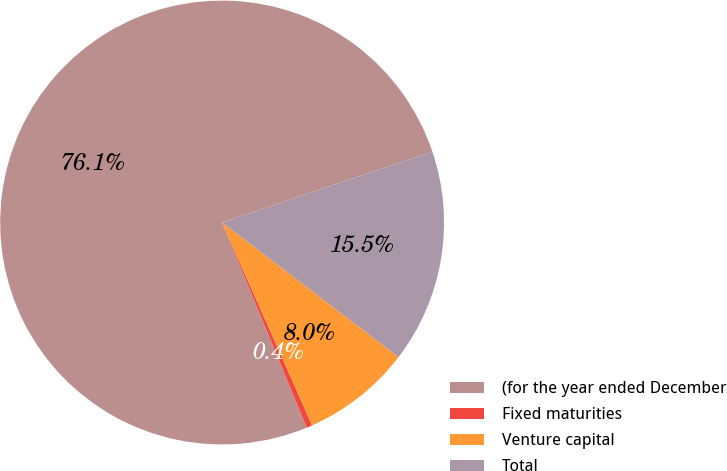Convert chart to OTSL. <chart><loc_0><loc_0><loc_500><loc_500><pie_chart><fcel>(for the year ended December<fcel>Fixed maturities<fcel>Venture capital<fcel>Total<nl><fcel>76.06%<fcel>0.42%<fcel>7.98%<fcel>15.55%<nl></chart> 